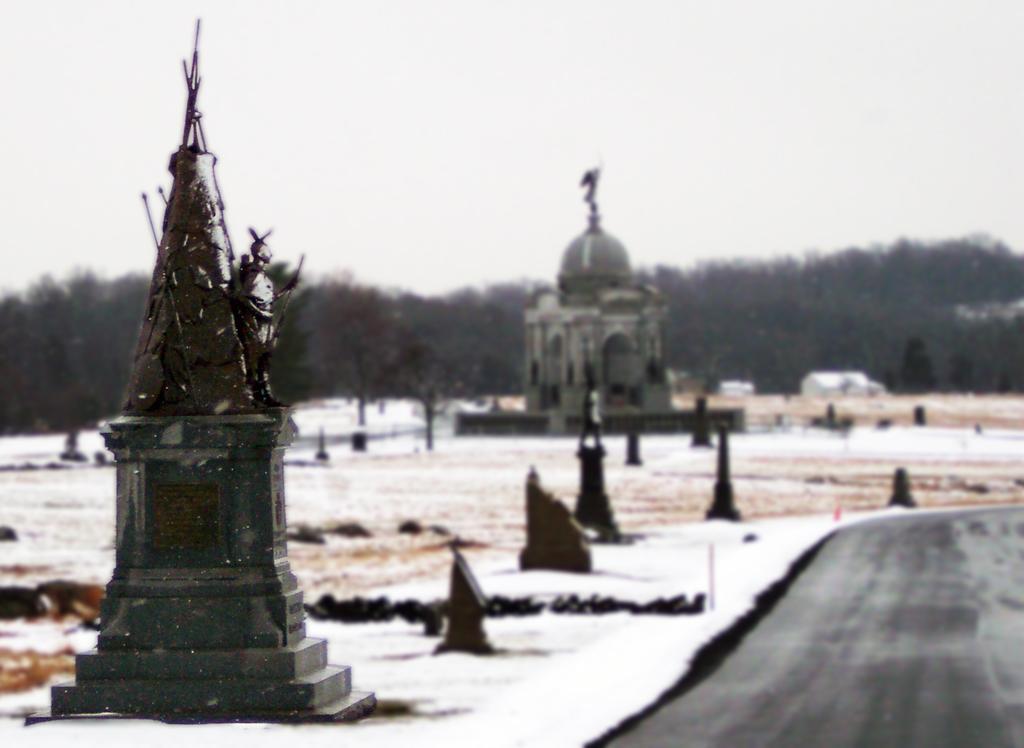In one or two sentences, can you explain what this image depicts? At the right bottom of the image there is a road. Beside the road to the left side there is a ground filled with snow. And also there are few poles. In the middle of the snow there is there is a tower. At the top of the image there is a sky. 